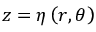Convert formula to latex. <formula><loc_0><loc_0><loc_500><loc_500>z = \eta \left ( r , \theta \right )</formula> 